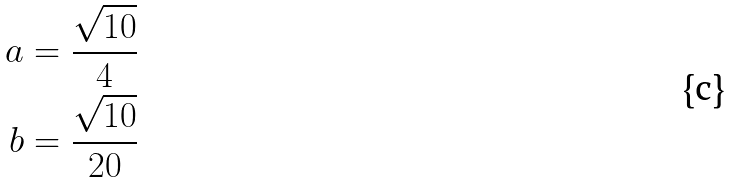Convert formula to latex. <formula><loc_0><loc_0><loc_500><loc_500>a = \frac { \sqrt { 1 0 } } { 4 } \\ b = \frac { \sqrt { 1 0 } } { 2 0 }</formula> 